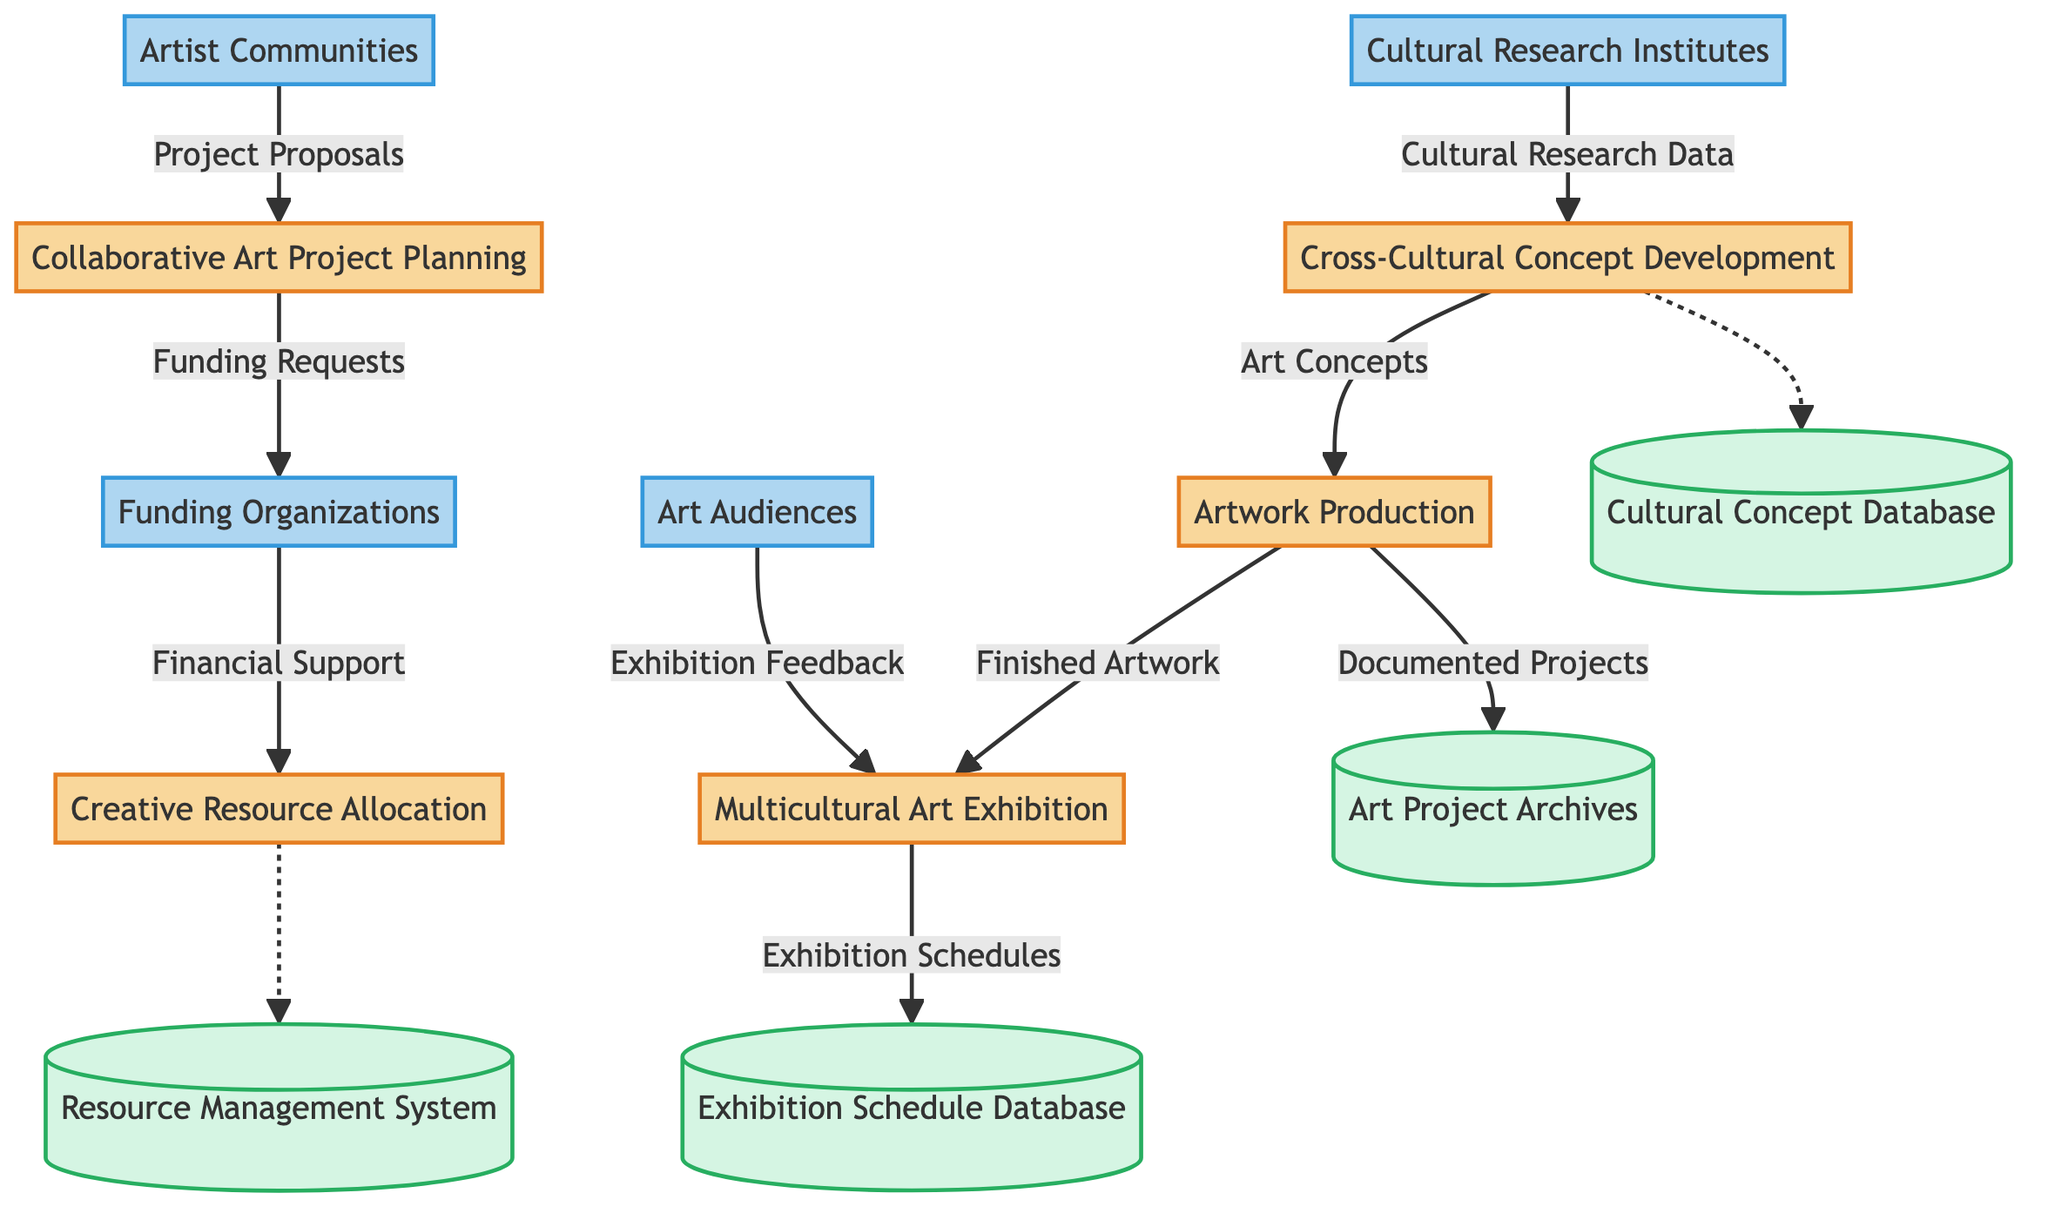What is the first process in the diagram? The first process is "Collaborative Art Project Planning," which is connected to artist communities through project proposals.
Answer: Collaborative Art Project Planning How many external entities are represented in the diagram? There are four external entities listed: Artist Communities, Funding Organizations, Art Audiences, and Cultural Research Institutes.
Answer: Four What data flows from the "Cross-Cultural Concept Development" process? The "Cross-Cultural Concept Development" process produces one data flow: "Art Concepts" which goes to "Artwork Production."
Answer: Art Concepts Which external entity provides financial support? The "Funding Organizations" provide the "Financial Support" to the "Creative Resource Allocation" process based on funding requests.
Answer: Funding Organizations What is the purpose of the "Art Project Archives" data store? The "Art Project Archives" data store is designed to store documentation and records of ongoing and completed art projects.
Answer: Documentation and records How does "Exhibition Feedback" reach the "Multicultural Art Exhibition"? "Exhibition Feedback" comes from "Art Audiences" and flows directly to the "Multicultural Art Exhibition" process.
Answer: Art Audiences What is the last process that produces output in the diagram? The last process that produces output is "Multicultural Art Exhibition," where finished artworks are exhibited to the public.
Answer: Multicultural Art Exhibition Which data flow indicates that cultural research data is obtained? The data flow for "Cultural Research Data" is sourced from "Cultural Research Institutes" and flows to the "Cross-Cultural Concept Development" process.
Answer: Cultural Research Data How many processes are illustrated in the diagram? There are five processes shown in the diagram: Collaborative Art Project Planning, Cross-Cultural Concept Development, Creative Resource Allocation, Artwork Production, and Multicultural Art Exhibition.
Answer: Five 